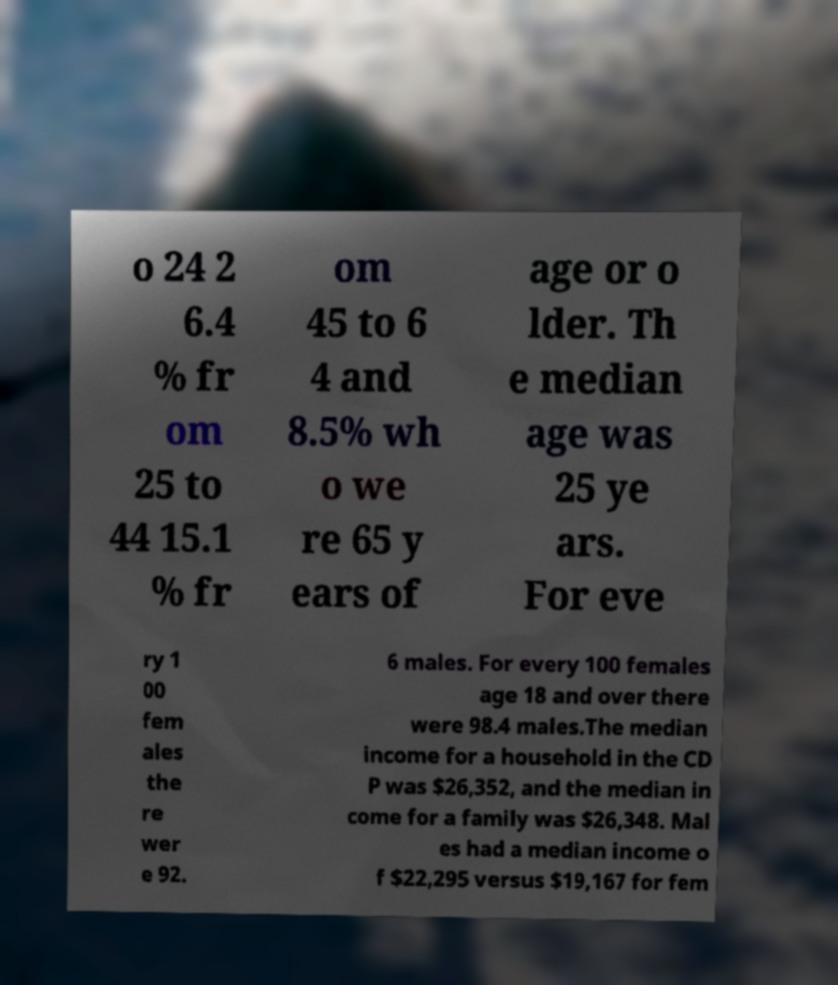For documentation purposes, I need the text within this image transcribed. Could you provide that? o 24 2 6.4 % fr om 25 to 44 15.1 % fr om 45 to 6 4 and 8.5% wh o we re 65 y ears of age or o lder. Th e median age was 25 ye ars. For eve ry 1 00 fem ales the re wer e 92. 6 males. For every 100 females age 18 and over there were 98.4 males.The median income for a household in the CD P was $26,352, and the median in come for a family was $26,348. Mal es had a median income o f $22,295 versus $19,167 for fem 